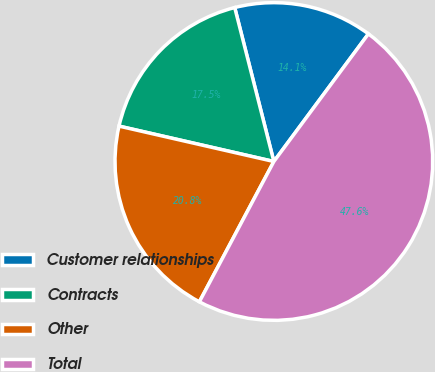Convert chart. <chart><loc_0><loc_0><loc_500><loc_500><pie_chart><fcel>Customer relationships<fcel>Contracts<fcel>Other<fcel>Total<nl><fcel>14.11%<fcel>17.46%<fcel>20.81%<fcel>47.62%<nl></chart> 